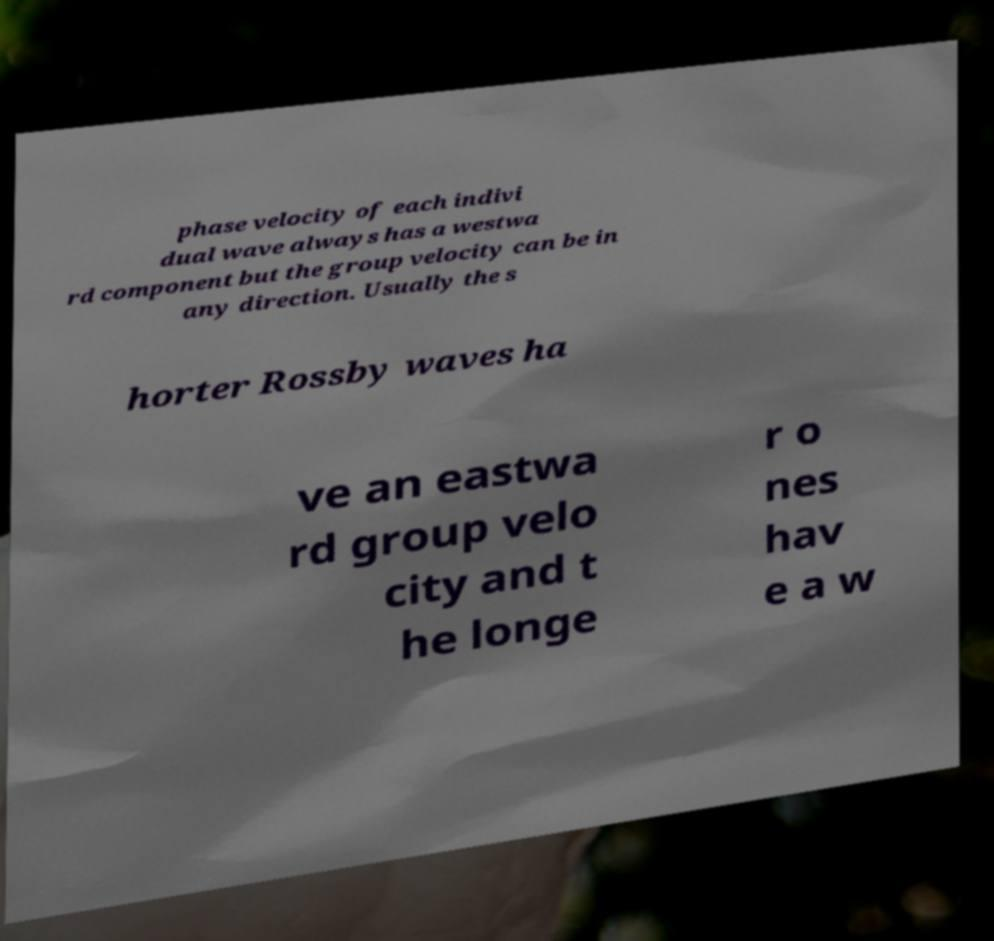Please identify and transcribe the text found in this image. phase velocity of each indivi dual wave always has a westwa rd component but the group velocity can be in any direction. Usually the s horter Rossby waves ha ve an eastwa rd group velo city and t he longe r o nes hav e a w 